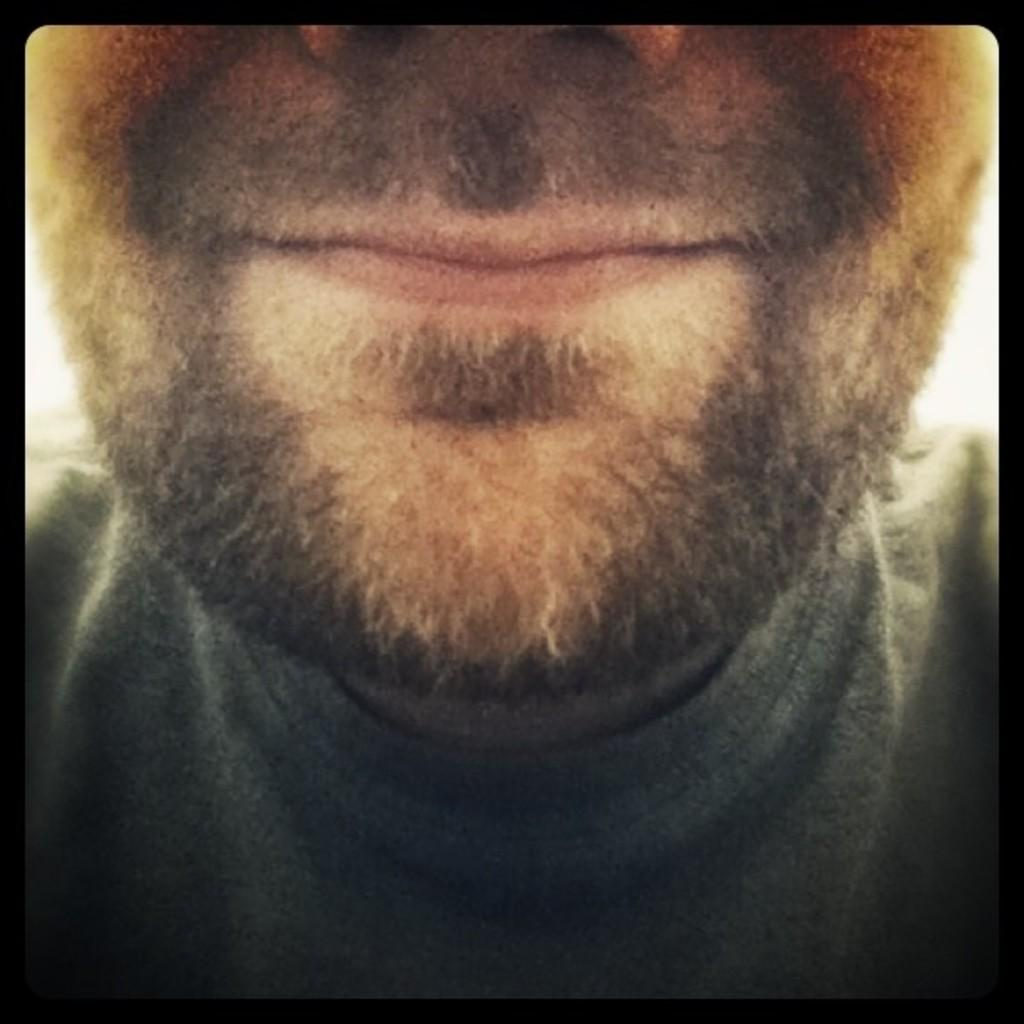What is the main subject of the image? The main subject of the image is the face of a man. What facial feature can be observed on the man? The man has a beard. What is the man wearing in the image? The man is wearing a black shirt. What type of animal is the man holding in the image? There is no animal present in the image; the man is not holding anything. What hobbies does the man have, as depicted in the image? The image does not provide any information about the man's hobbies. 